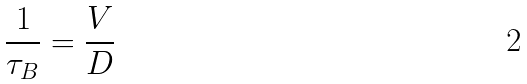Convert formula to latex. <formula><loc_0><loc_0><loc_500><loc_500>\frac { 1 } { \tau _ { B } } = \frac { V } { D }</formula> 